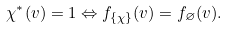Convert formula to latex. <formula><loc_0><loc_0><loc_500><loc_500>\chi ^ { * } ( v ) = 1 \Leftrightarrow f _ { \{ \chi \} } ( v ) = f _ { \varnothing } ( v ) .</formula> 